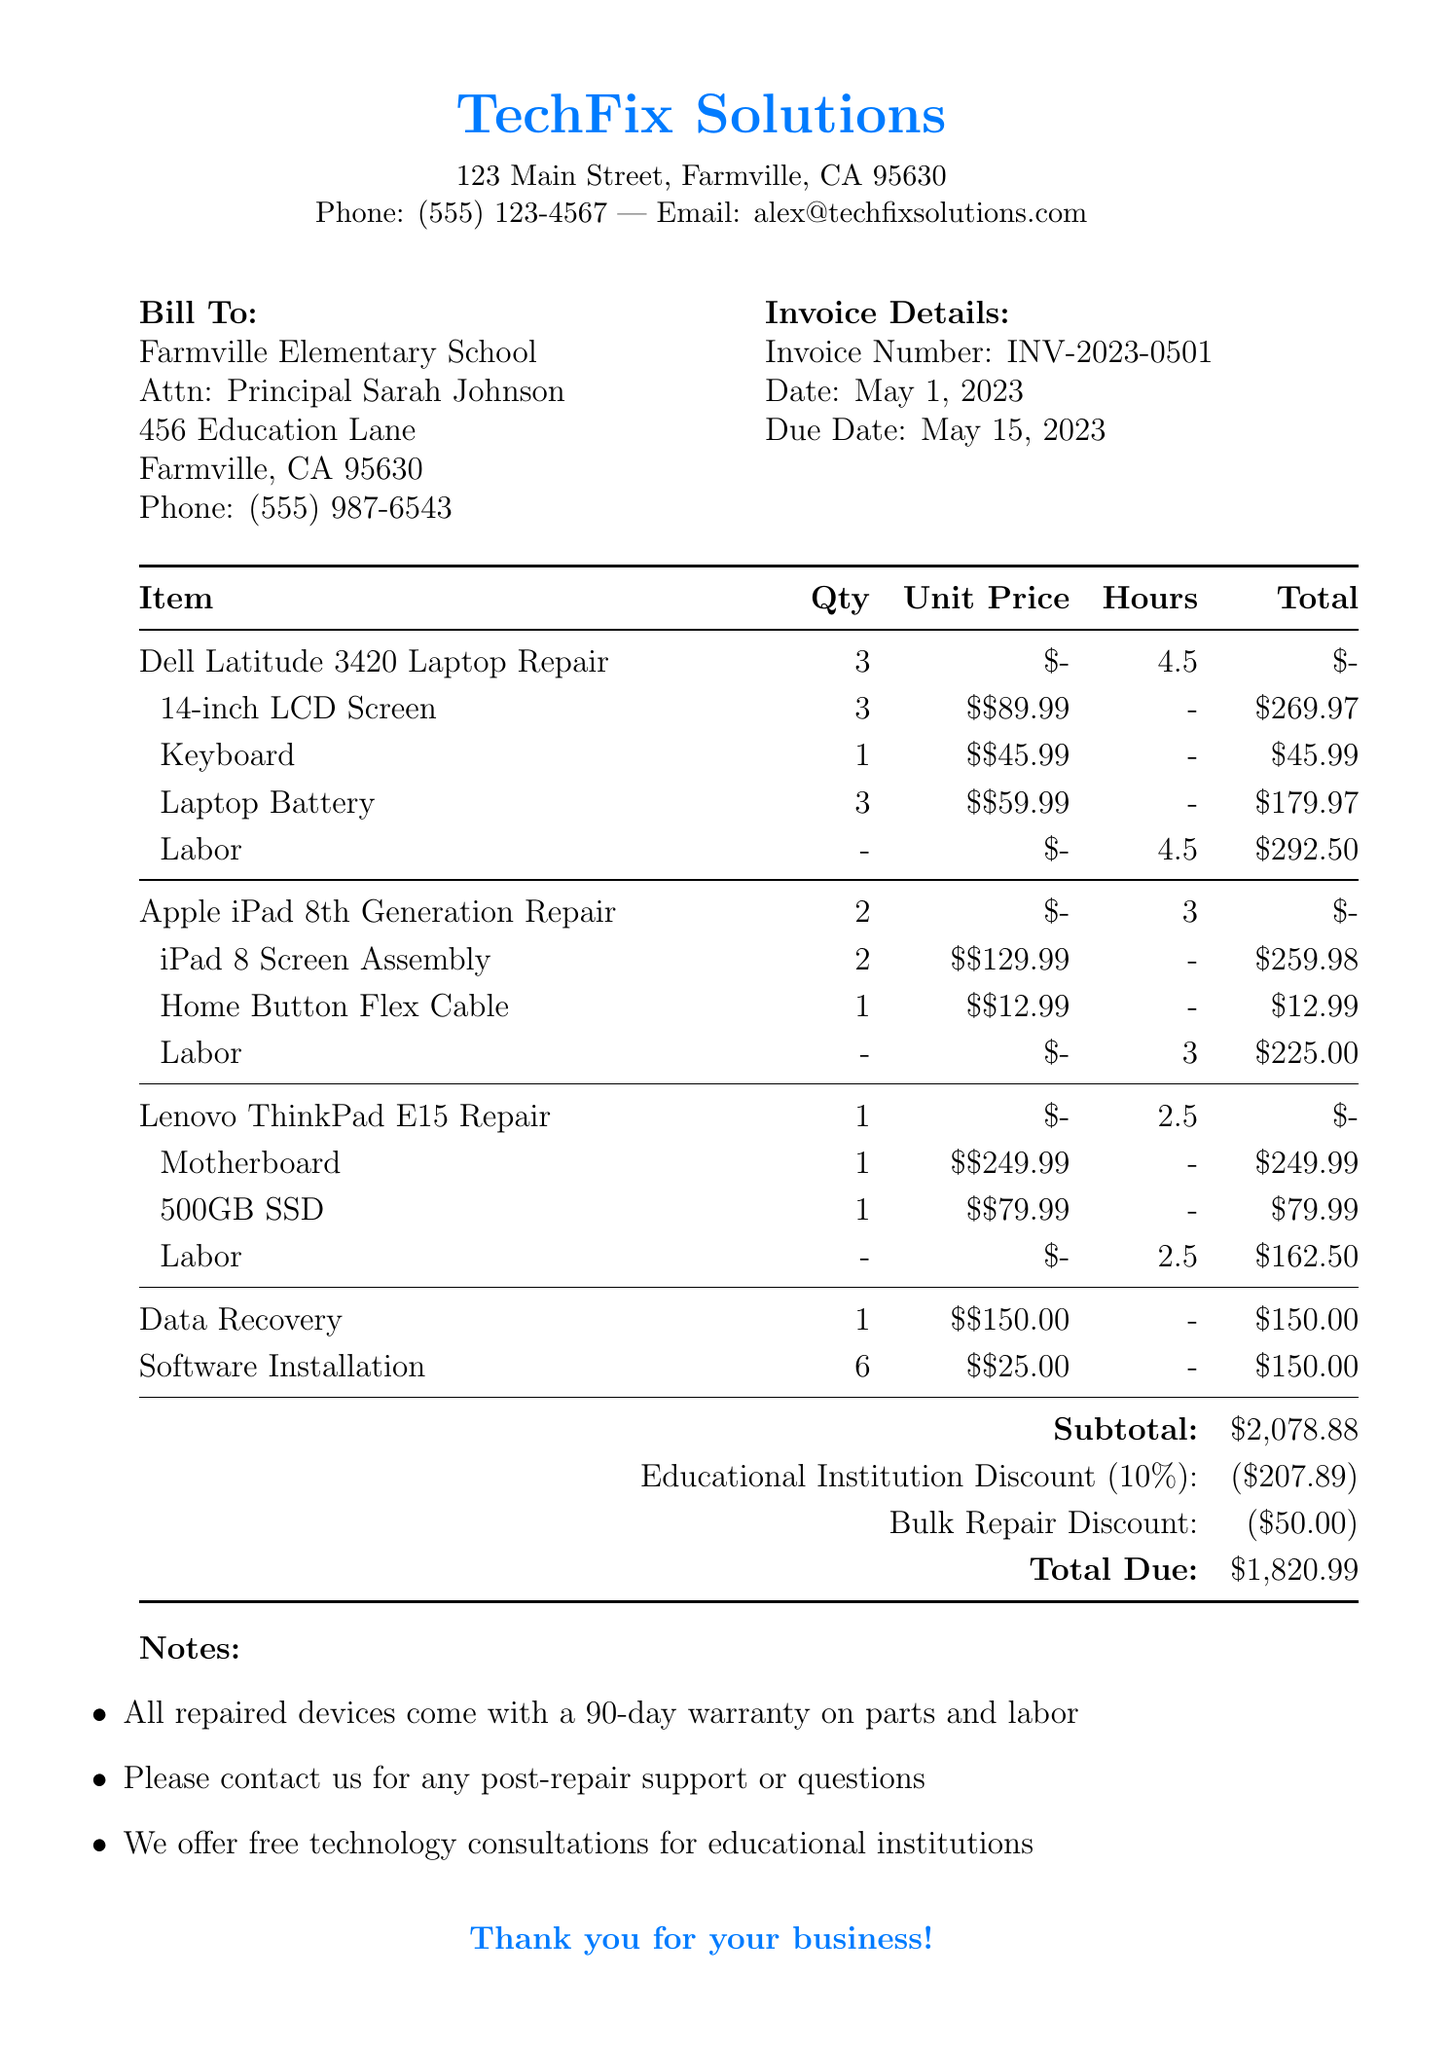What is the invoice number? The invoice number is specified in the invoice details section of the document.
Answer: INV-2023-0501 What is the name of the business? The name of the business is listed at the top of the document in the business info section.
Answer: TechFix Solutions How many Dell Latitude laptops were repaired? The quantity of Dell Latitude laptops is listed under the repair items for this device.
Answer: 3 What is the total due amount? The total due is calculated and summarized at the end of the invoice document.
Answer: $1,820.99 What is the educational institution discount percentage? The discount percentage for educational institutions is stated in the discounts section.
Answer: 10% How many iPad 8th Generation devices were repaired? The quantity of iPad 8th Generation devices is mentioned in the repair items section.
Answer: 2 What is the labor rate for the Apple iPad repairs? The labor rate for the Apple iPad repairs is included with the labor details for this device.
Answer: $75 What is the subtotal before discounts? The subtotal is calculated and displayed in the summary section before any discounts are applied.
Answer: $2,078.88 What additional service was provided for the Lenovo ThinkPad? The additional service for the Lenovo ThinkPad is stated in the additional services section of the document.
Answer: Data Recovery 